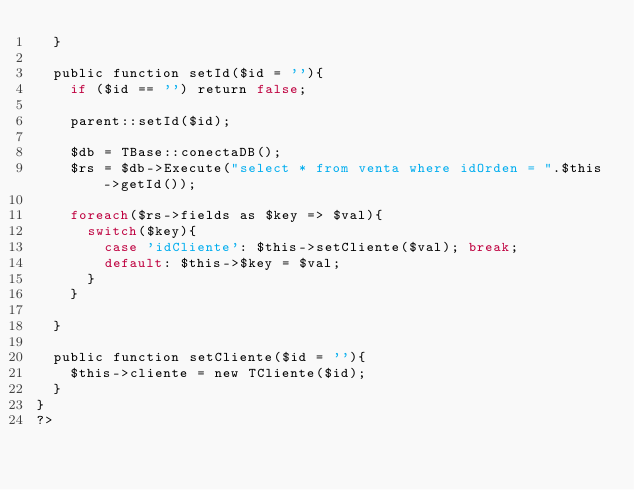Convert code to text. <code><loc_0><loc_0><loc_500><loc_500><_PHP_>	}
	
	public function setId($id = ''){
		if ($id == '') return false;
		
		parent::setId($id);
		
		$db = TBase::conectaDB();
		$rs = $db->Execute("select * from venta where idOrden = ".$this->getId());
		
		foreach($rs->fields as $key => $val){
			switch($key){
				case 'idCliente': $this->setCliente($val); break;
				default: $this->$key = $val;
			}
		}

	}
	
	public function setCliente($id = ''){
		$this->cliente = new TCliente($id);
	}
}
?></code> 